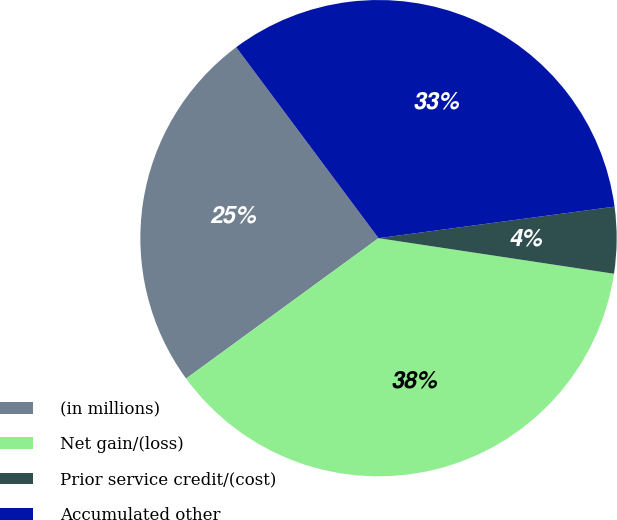Convert chart to OTSL. <chart><loc_0><loc_0><loc_500><loc_500><pie_chart><fcel>(in millions)<fcel>Net gain/(loss)<fcel>Prior service credit/(cost)<fcel>Accumulated other<nl><fcel>24.84%<fcel>37.58%<fcel>4.5%<fcel>33.08%<nl></chart> 